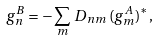<formula> <loc_0><loc_0><loc_500><loc_500>g _ { n } ^ { B } = - \sum _ { m } \, D _ { n m } \, ( g _ { m } ^ { A } ) ^ { \ast } ,</formula> 